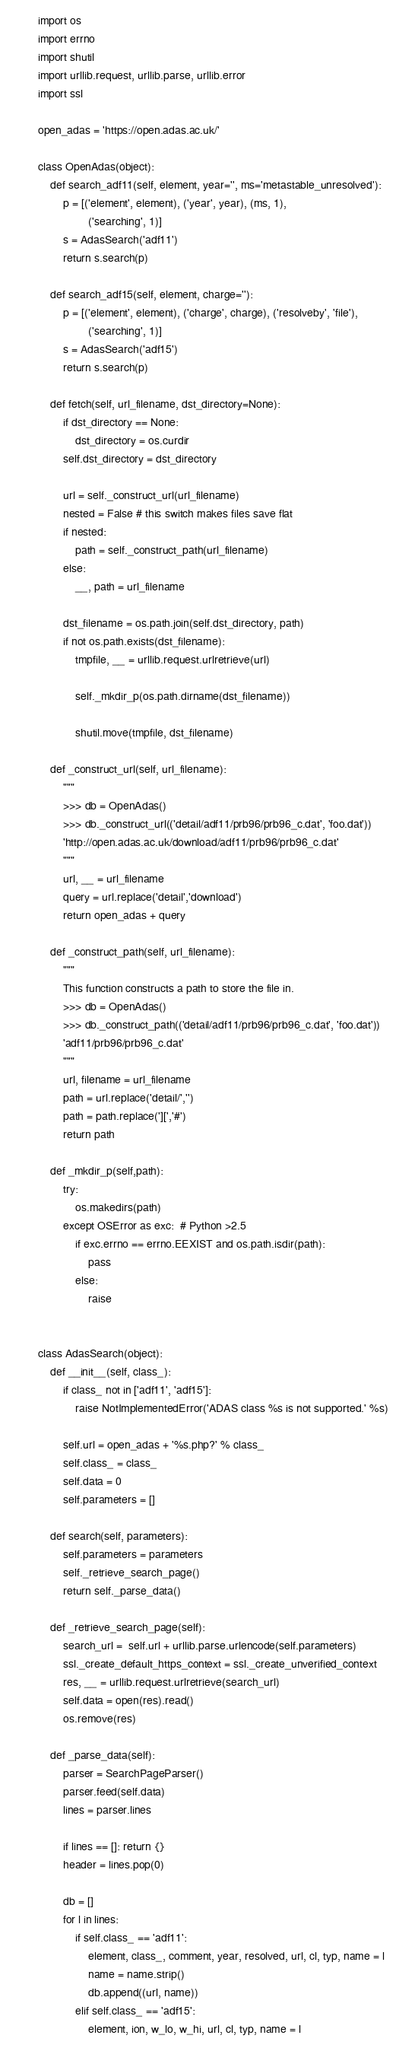<code> <loc_0><loc_0><loc_500><loc_500><_Python_>import os
import errno
import shutil
import urllib.request, urllib.parse, urllib.error
import ssl

open_adas = 'https://open.adas.ac.uk/'

class OpenAdas(object):
    def search_adf11(self, element, year='', ms='metastable_unresolved'):
        p = [('element', element), ('year', year), (ms, 1),
                ('searching', 1)]
        s = AdasSearch('adf11')
        return s.search(p)

    def search_adf15(self, element, charge=''):
        p = [('element', element), ('charge', charge), ('resolveby', 'file'),
                ('searching', 1)]
        s = AdasSearch('adf15')
        return s.search(p)

    def fetch(self, url_filename, dst_directory=None):
        if dst_directory == None:
            dst_directory = os.curdir
        self.dst_directory = dst_directory

        url = self._construct_url(url_filename)
        nested = False # this switch makes files save flat
        if nested:
            path = self._construct_path(url_filename)
        else:
            __, path = url_filename

        dst_filename = os.path.join(self.dst_directory, path)
        if not os.path.exists(dst_filename):
            tmpfile, __ = urllib.request.urlretrieve(url)

            self._mkdir_p(os.path.dirname(dst_filename))

            shutil.move(tmpfile, dst_filename)

    def _construct_url(self, url_filename):
        """
        >>> db = OpenAdas()
        >>> db._construct_url(('detail/adf11/prb96/prb96_c.dat', 'foo.dat'))
        'http://open.adas.ac.uk/download/adf11/prb96/prb96_c.dat'
        """
        url, __ = url_filename
        query = url.replace('detail','download')
        return open_adas + query

    def _construct_path(self, url_filename):
        """
        This function constructs a path to store the file in.
        >>> db = OpenAdas()
        >>> db._construct_path(('detail/adf11/prb96/prb96_c.dat', 'foo.dat'))
        'adf11/prb96/prb96_c.dat'
        """
        url, filename = url_filename
        path = url.replace('detail/','')
        path = path.replace('][','#')
        return path

    def _mkdir_p(self,path):
        try:
            os.makedirs(path)
        except OSError as exc:  # Python >2.5
            if exc.errno == errno.EEXIST and os.path.isdir(path):
                pass
            else:
                raise


class AdasSearch(object):
    def __init__(self, class_):
        if class_ not in ['adf11', 'adf15']:
            raise NotImplementedError('ADAS class %s is not supported.' %s)

        self.url = open_adas + '%s.php?' % class_
        self.class_ = class_
        self.data = 0
        self.parameters = []

    def search(self, parameters):
        self.parameters = parameters
        self._retrieve_search_page()
        return self._parse_data()

    def _retrieve_search_page(self):
        search_url =  self.url + urllib.parse.urlencode(self.parameters)
        ssl._create_default_https_context = ssl._create_unverified_context
        res, __ = urllib.request.urlretrieve(search_url)
        self.data = open(res).read()
        os.remove(res)

    def _parse_data(self):
        parser = SearchPageParser()
        parser.feed(self.data)
        lines = parser.lines

        if lines == []: return {}
        header = lines.pop(0)

        db = []
        for l in lines:
            if self.class_ == 'adf11':
                element, class_, comment, year, resolved, url, cl, typ, name = l
                name = name.strip()
                db.append((url, name))
            elif self.class_ == 'adf15':
                element, ion, w_lo, w_hi, url, cl, typ, name = l</code> 